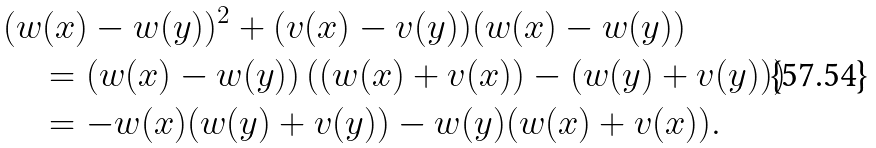<formula> <loc_0><loc_0><loc_500><loc_500>& ( w ( x ) - w ( y ) ) ^ { 2 } + ( v ( x ) - v ( y ) ) ( w ( x ) - w ( y ) ) \\ & \quad = ( w ( x ) - w ( y ) ) \left ( ( w ( x ) + v ( x ) ) - ( w ( y ) + v ( y ) ) \right ) \\ & \quad = - w ( x ) ( w ( y ) + v ( y ) ) - w ( y ) ( w ( x ) + v ( x ) ) .</formula> 